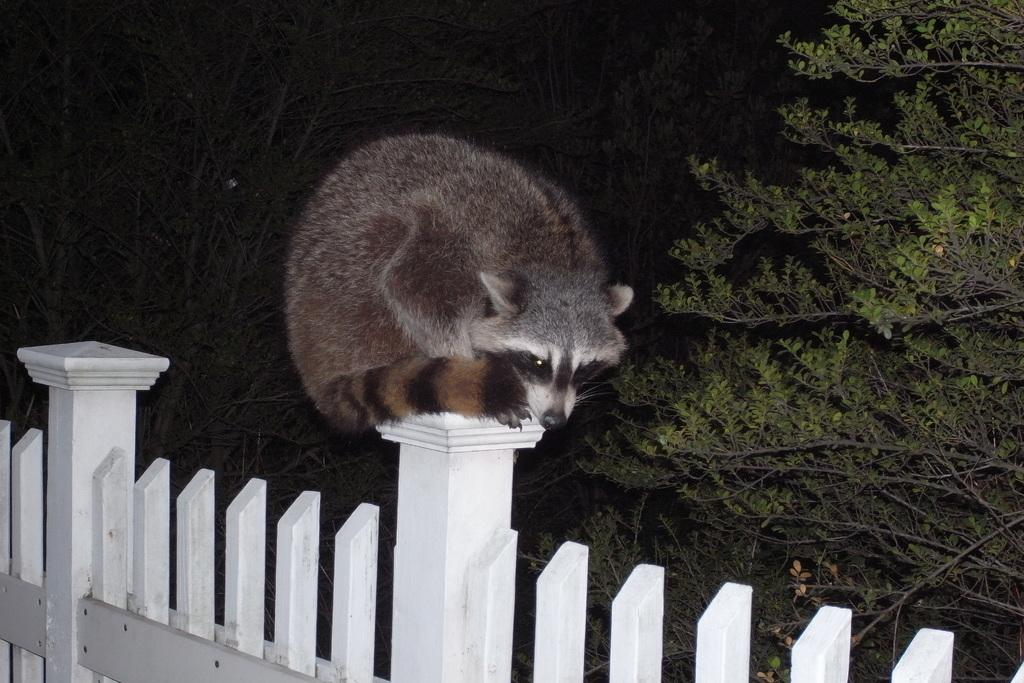What type of animal is present in the image? There is an animal in the image, but the specific type cannot be determined from the provided facts. What is the animal standing near in the image? There is a fence in the image, and the animal is likely standing near it. What can be seen in the distance in the image? There are trees in the background of the image. What type of ring is the animal wearing on its front leg in the image? There is no ring present on the animal's front leg in the image. 